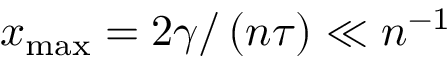Convert formula to latex. <formula><loc_0><loc_0><loc_500><loc_500>x _ { \max } = 2 \gamma / \left ( n \tau \right ) \ll n ^ { - 1 }</formula> 